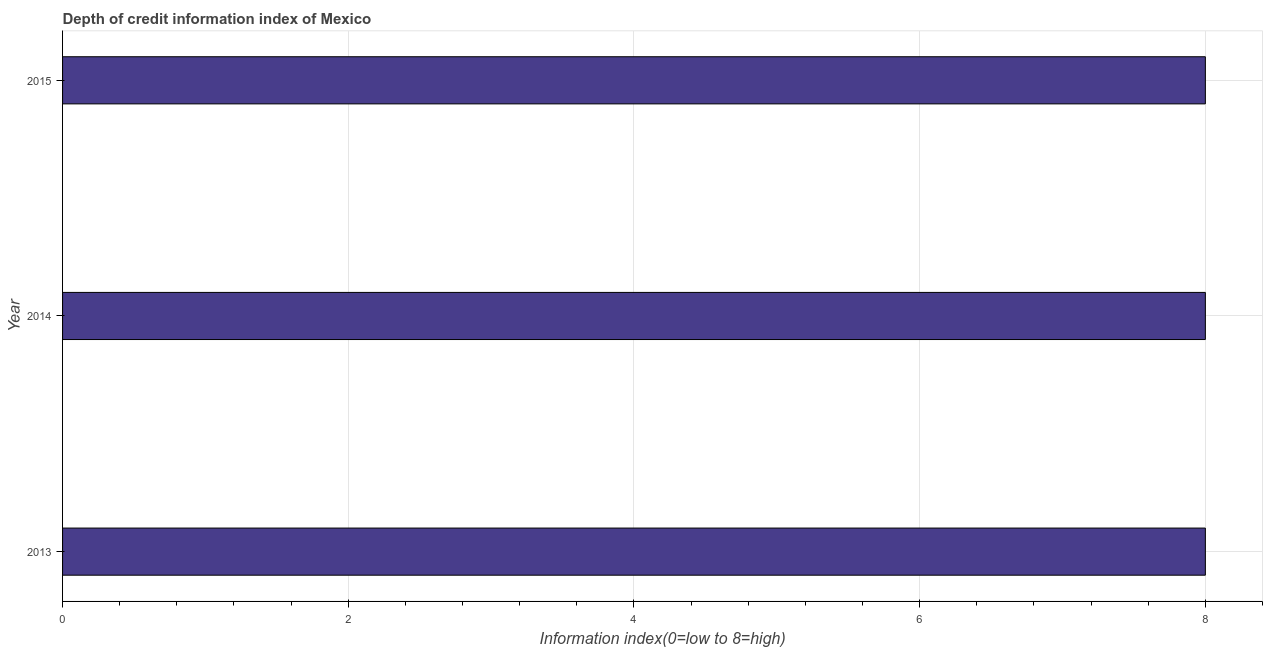Does the graph contain grids?
Ensure brevity in your answer.  Yes. What is the title of the graph?
Your answer should be compact. Depth of credit information index of Mexico. What is the label or title of the X-axis?
Give a very brief answer. Information index(0=low to 8=high). What is the label or title of the Y-axis?
Keep it short and to the point. Year. What is the depth of credit information index in 2015?
Provide a short and direct response. 8. Across all years, what is the minimum depth of credit information index?
Your response must be concise. 8. In which year was the depth of credit information index maximum?
Your answer should be compact. 2013. In which year was the depth of credit information index minimum?
Give a very brief answer. 2013. What is the sum of the depth of credit information index?
Provide a short and direct response. 24. What is the difference between the depth of credit information index in 2013 and 2015?
Make the answer very short. 0. What is the average depth of credit information index per year?
Your answer should be very brief. 8. What is the median depth of credit information index?
Offer a terse response. 8. What is the ratio of the depth of credit information index in 2013 to that in 2015?
Ensure brevity in your answer.  1. Is the difference between the depth of credit information index in 2014 and 2015 greater than the difference between any two years?
Give a very brief answer. Yes. What is the difference between the highest and the second highest depth of credit information index?
Give a very brief answer. 0. What is the difference between the highest and the lowest depth of credit information index?
Provide a succinct answer. 0. How many bars are there?
Keep it short and to the point. 3. Are all the bars in the graph horizontal?
Make the answer very short. Yes. What is the Information index(0=low to 8=high) of 2013?
Provide a succinct answer. 8. What is the Information index(0=low to 8=high) of 2014?
Give a very brief answer. 8. What is the ratio of the Information index(0=low to 8=high) in 2013 to that in 2014?
Provide a succinct answer. 1. What is the ratio of the Information index(0=low to 8=high) in 2013 to that in 2015?
Offer a very short reply. 1. 